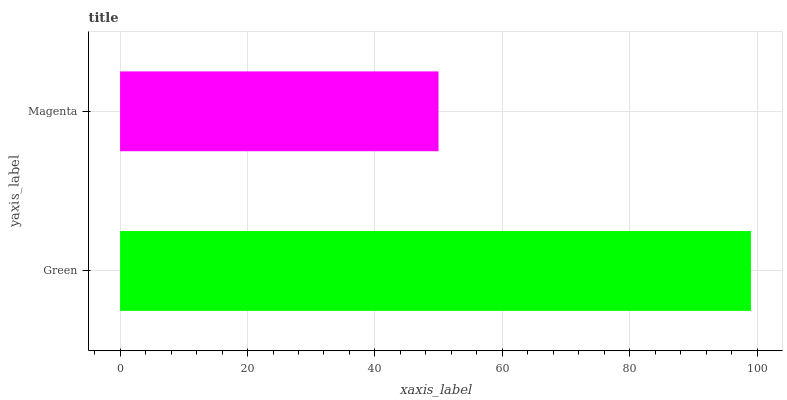Is Magenta the minimum?
Answer yes or no. Yes. Is Green the maximum?
Answer yes or no. Yes. Is Magenta the maximum?
Answer yes or no. No. Is Green greater than Magenta?
Answer yes or no. Yes. Is Magenta less than Green?
Answer yes or no. Yes. Is Magenta greater than Green?
Answer yes or no. No. Is Green less than Magenta?
Answer yes or no. No. Is Green the high median?
Answer yes or no. Yes. Is Magenta the low median?
Answer yes or no. Yes. Is Magenta the high median?
Answer yes or no. No. Is Green the low median?
Answer yes or no. No. 